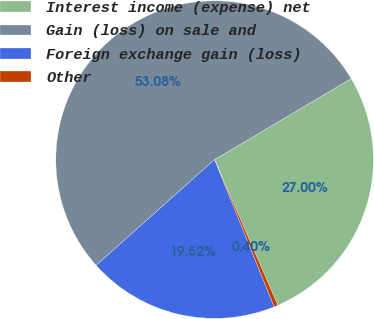<chart> <loc_0><loc_0><loc_500><loc_500><pie_chart><fcel>Interest income (expense) net<fcel>Gain (loss) on sale and<fcel>Foreign exchange gain (loss)<fcel>Other<nl><fcel>27.0%<fcel>53.07%<fcel>19.52%<fcel>0.4%<nl></chart> 